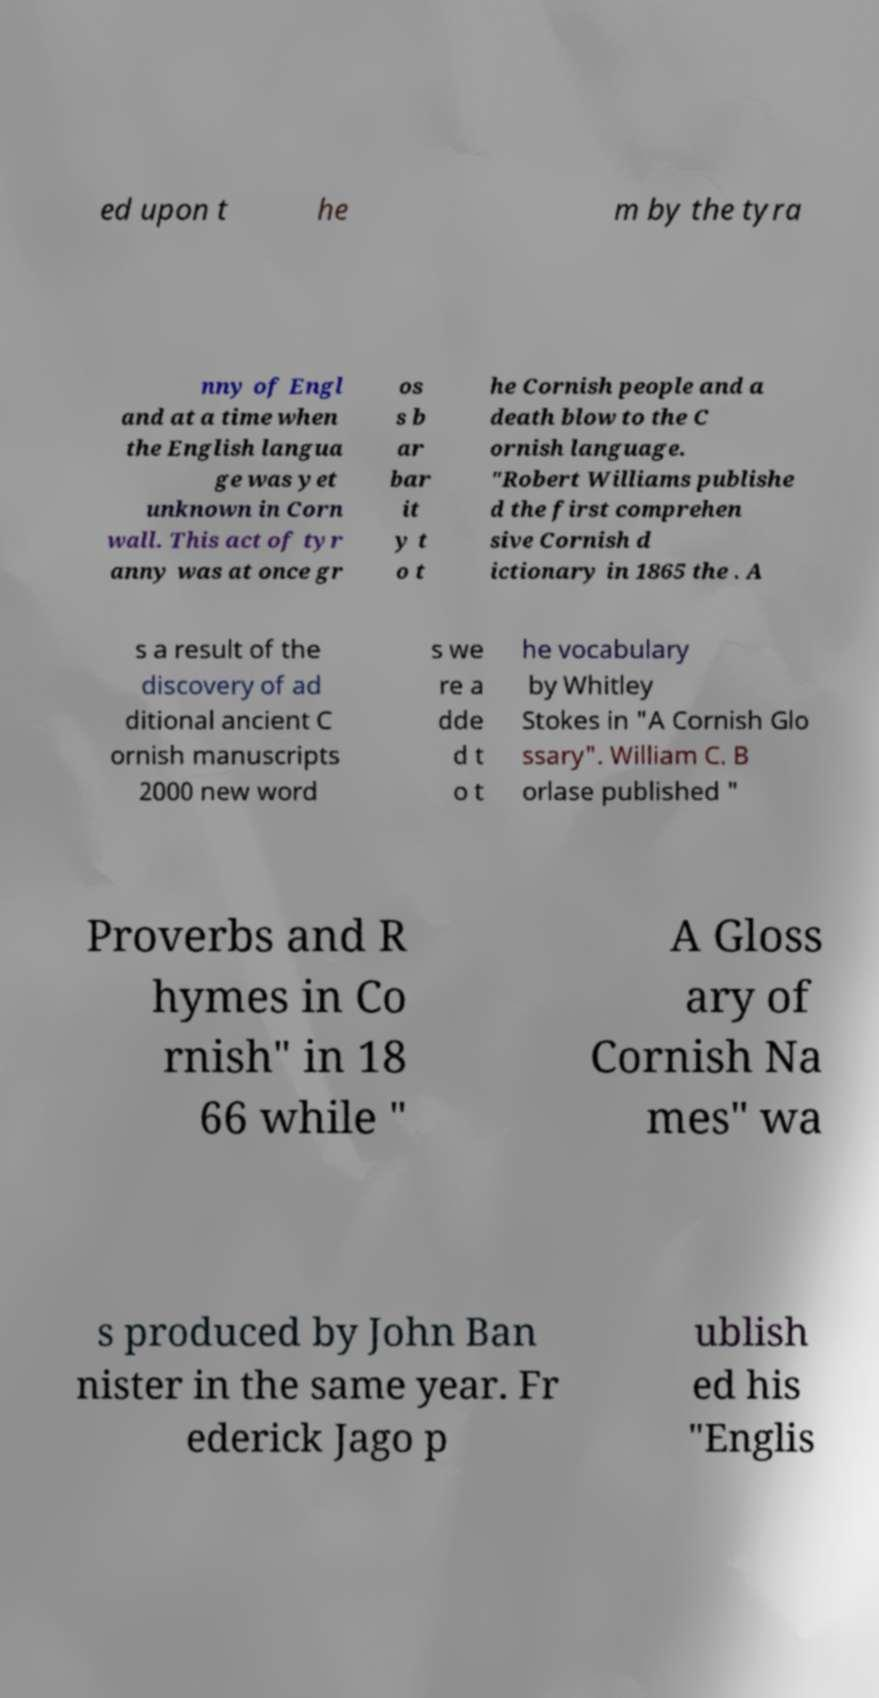What messages or text are displayed in this image? I need them in a readable, typed format. ed upon t he m by the tyra nny of Engl and at a time when the English langua ge was yet unknown in Corn wall. This act of tyr anny was at once gr os s b ar bar it y t o t he Cornish people and a death blow to the C ornish language. "Robert Williams publishe d the first comprehen sive Cornish d ictionary in 1865 the . A s a result of the discovery of ad ditional ancient C ornish manuscripts 2000 new word s we re a dde d t o t he vocabulary by Whitley Stokes in "A Cornish Glo ssary". William C. B orlase published " Proverbs and R hymes in Co rnish" in 18 66 while " A Gloss ary of Cornish Na mes" wa s produced by John Ban nister in the same year. Fr ederick Jago p ublish ed his "Englis 